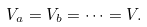Convert formula to latex. <formula><loc_0><loc_0><loc_500><loc_500>V _ { a } = V _ { b } = \cdots = V .</formula> 